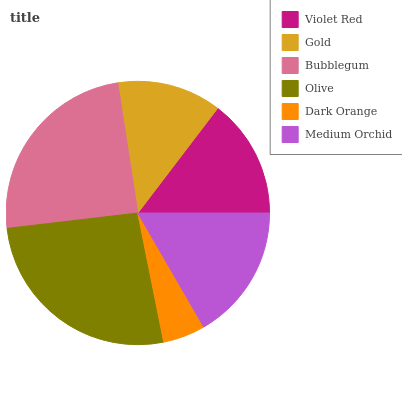Is Dark Orange the minimum?
Answer yes or no. Yes. Is Olive the maximum?
Answer yes or no. Yes. Is Gold the minimum?
Answer yes or no. No. Is Gold the maximum?
Answer yes or no. No. Is Violet Red greater than Gold?
Answer yes or no. Yes. Is Gold less than Violet Red?
Answer yes or no. Yes. Is Gold greater than Violet Red?
Answer yes or no. No. Is Violet Red less than Gold?
Answer yes or no. No. Is Medium Orchid the high median?
Answer yes or no. Yes. Is Violet Red the low median?
Answer yes or no. Yes. Is Dark Orange the high median?
Answer yes or no. No. Is Gold the low median?
Answer yes or no. No. 